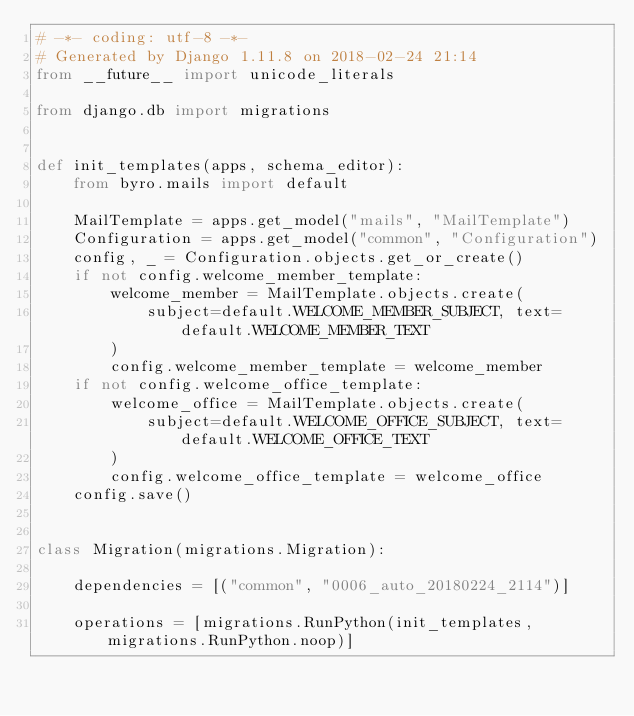Convert code to text. <code><loc_0><loc_0><loc_500><loc_500><_Python_># -*- coding: utf-8 -*-
# Generated by Django 1.11.8 on 2018-02-24 21:14
from __future__ import unicode_literals

from django.db import migrations


def init_templates(apps, schema_editor):
    from byro.mails import default

    MailTemplate = apps.get_model("mails", "MailTemplate")
    Configuration = apps.get_model("common", "Configuration")
    config, _ = Configuration.objects.get_or_create()
    if not config.welcome_member_template:
        welcome_member = MailTemplate.objects.create(
            subject=default.WELCOME_MEMBER_SUBJECT, text=default.WELCOME_MEMBER_TEXT
        )
        config.welcome_member_template = welcome_member
    if not config.welcome_office_template:
        welcome_office = MailTemplate.objects.create(
            subject=default.WELCOME_OFFICE_SUBJECT, text=default.WELCOME_OFFICE_TEXT
        )
        config.welcome_office_template = welcome_office
    config.save()


class Migration(migrations.Migration):

    dependencies = [("common", "0006_auto_20180224_2114")]

    operations = [migrations.RunPython(init_templates, migrations.RunPython.noop)]
</code> 